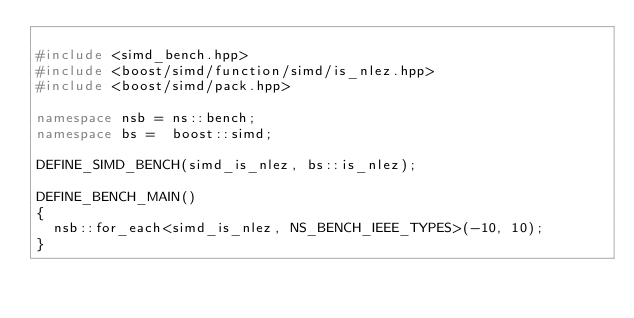Convert code to text. <code><loc_0><loc_0><loc_500><loc_500><_C++_>
#include <simd_bench.hpp>
#include <boost/simd/function/simd/is_nlez.hpp>
#include <boost/simd/pack.hpp>

namespace nsb = ns::bench;
namespace bs =  boost::simd;

DEFINE_SIMD_BENCH(simd_is_nlez, bs::is_nlez);

DEFINE_BENCH_MAIN()
{
  nsb::for_each<simd_is_nlez, NS_BENCH_IEEE_TYPES>(-10, 10);
}
</code> 